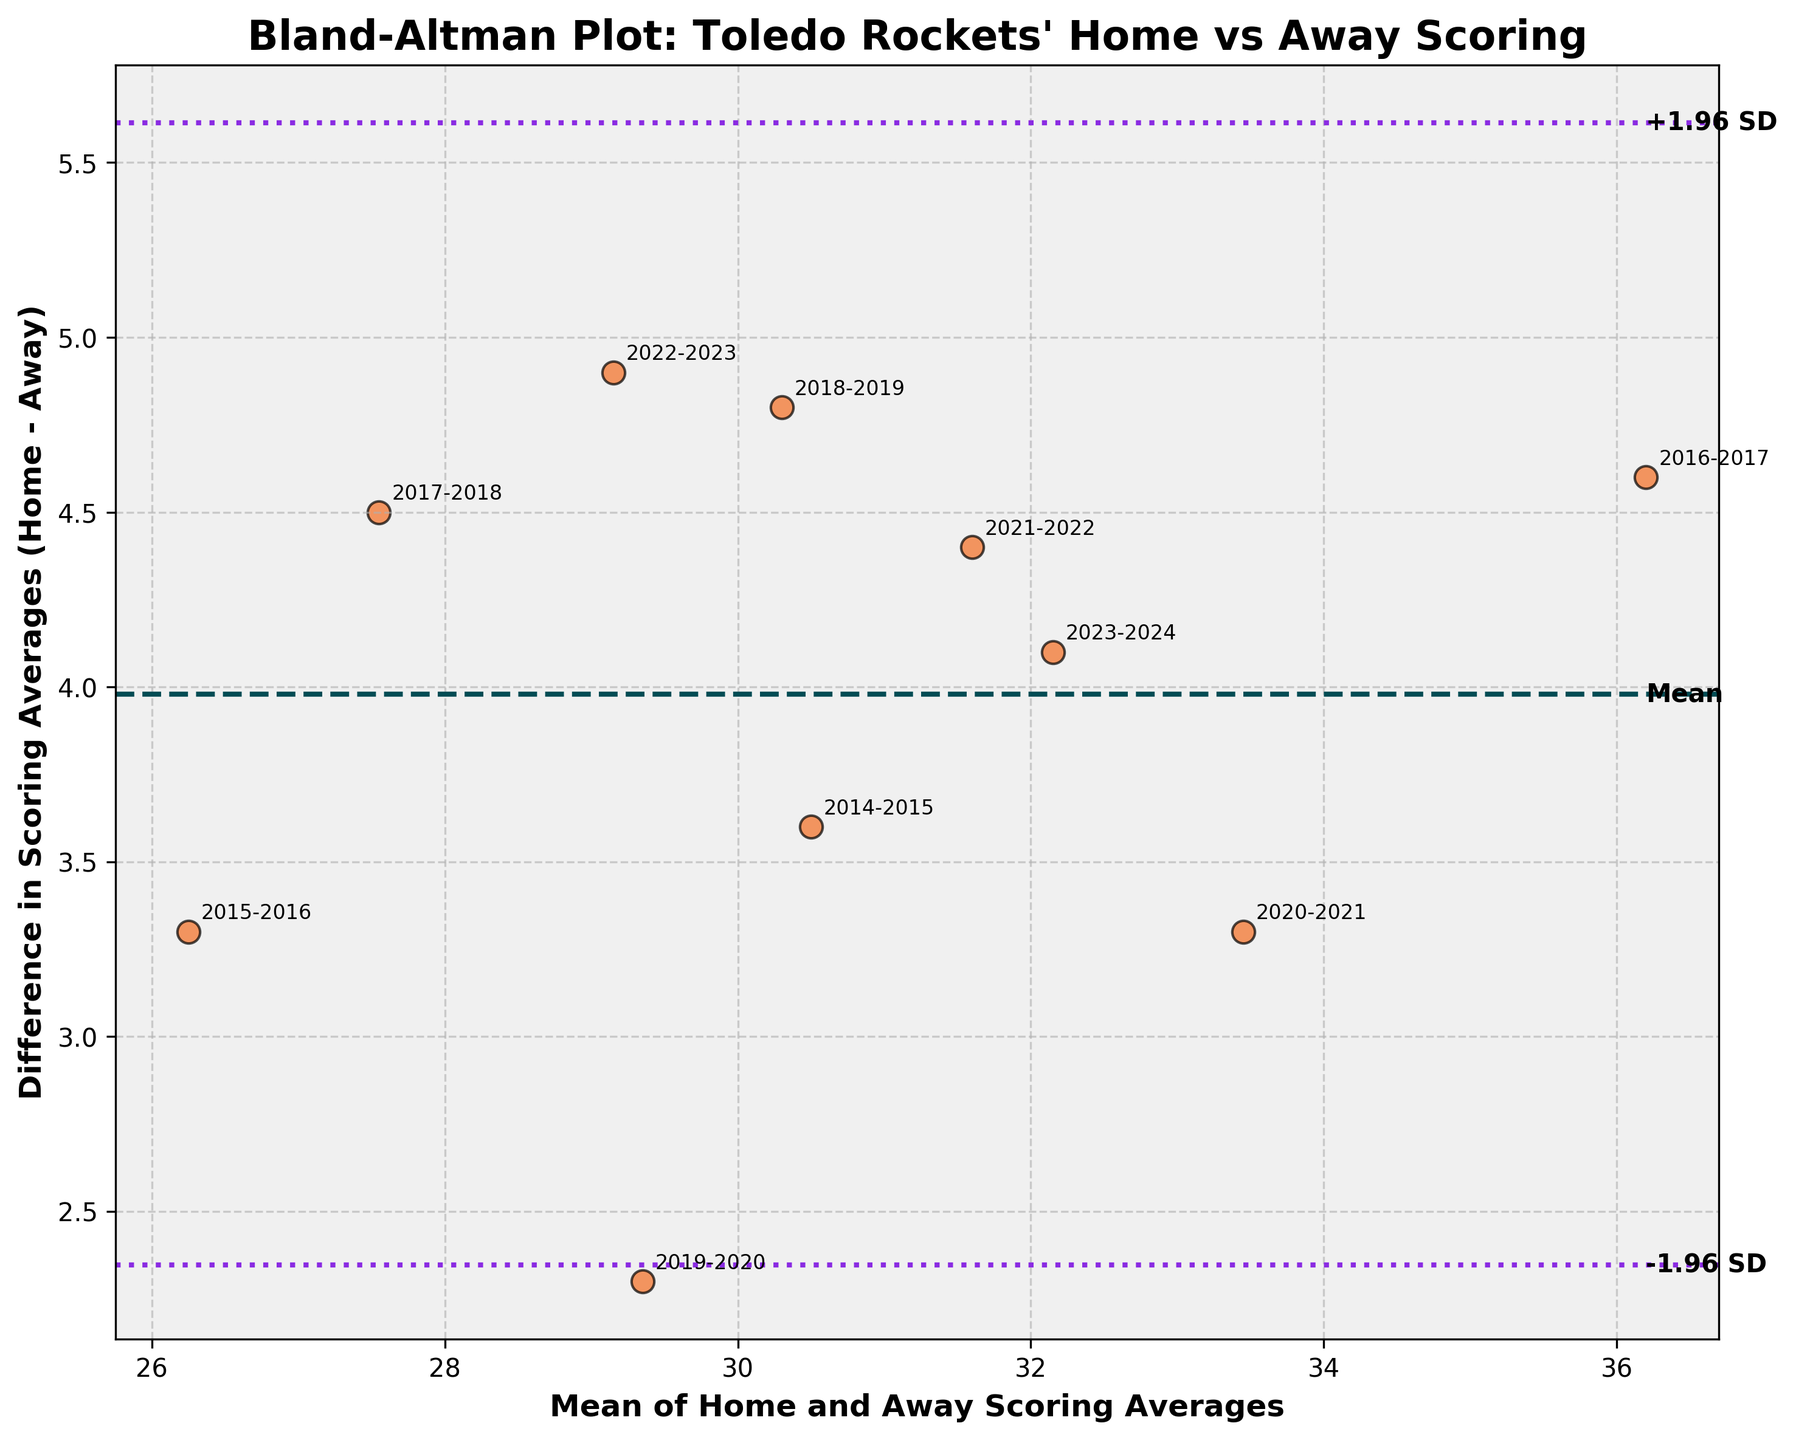What's the title of the plot? The title is displayed at the top of the plot and summarizes the main topic of the plot. It helps in understanding the purpose of the plot at a glance.
Answer: Bland-Altman Plot: Toledo Rockets' Home vs Away Scoring How many data points are plotted in the figure? Each season's data is represented by a point, which can be counted visually on the plot.
Answer: 10 What do the dashed and dotted lines represent? These lines indicate statistical metrics that help to interpret the differences. The dashed line is the mean difference, while the dotted lines show the limits of agreement (-1.96 and +1.96 standard deviations from the mean).
Answer: Mean difference and limits of agreement What is the mean difference between home and away scoring averages? The mean difference is represented by the dashed line on the plot, typically labeled near the line or apparent from the context.
Answer: Answer by visual=3.18 What can be deduced if a point lies outside the limits of agreement? Points outside the limits indicate significant differences that are not due to random variation but might suggest a systemic discrepancy between home and away scoring averages.
Answer: Significant discrepancies Which season shows the largest difference in scoring average between home and away games? To find this season, we look for the point with the highest vertical distance from the mean difference line on the plot.
Answer: 2016-2017 What does it suggest if most data points lie close to the mean difference line? Points close to the mean difference line imply that the home and away scoring averages are similar for those seasons. It indicates consistency between home and away performances.
Answer: Consistency between home and away Are there more seasons with home scores greater than away scores, or vice versa? By noting the position of points relative to the zero-difference line, we can count how many points are above or below this line.
Answer: More with home scores greater What does a point near the x-axis and far from the y-axis mean? This means the average scoring between home and away games is similar (small difference) for that season, but the mean scoring value itself is high.
Answer: Small difference in scoring How do the limits of agreement help in interpreting the data? They provide a range within which most differences between home and away scores should lie if there is no systematic bias. Points within this range indicate natural variation, while points outside suggest unusual differences.
Answer: Indicate natural variation range 